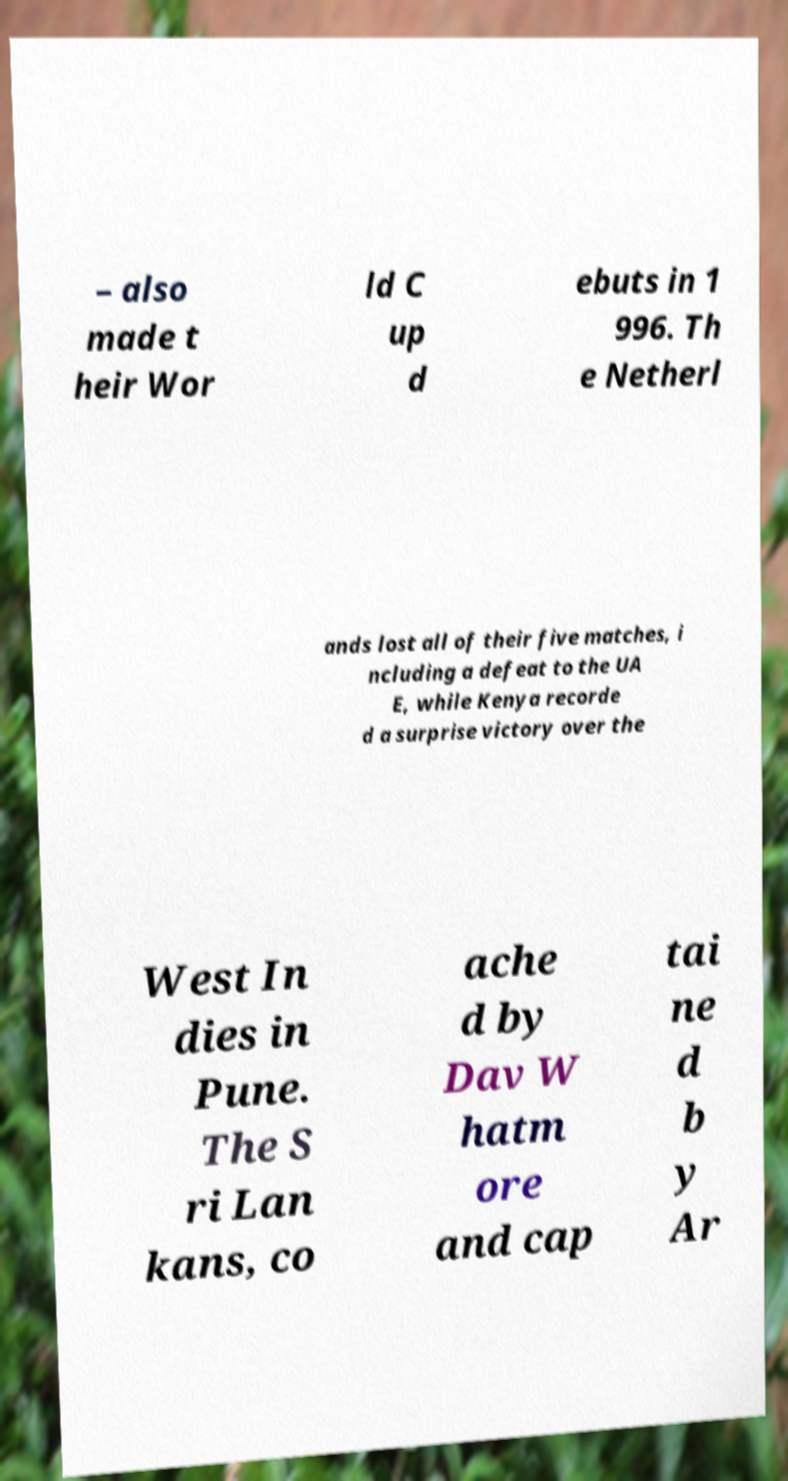There's text embedded in this image that I need extracted. Can you transcribe it verbatim? – also made t heir Wor ld C up d ebuts in 1 996. Th e Netherl ands lost all of their five matches, i ncluding a defeat to the UA E, while Kenya recorde d a surprise victory over the West In dies in Pune. The S ri Lan kans, co ache d by Dav W hatm ore and cap tai ne d b y Ar 